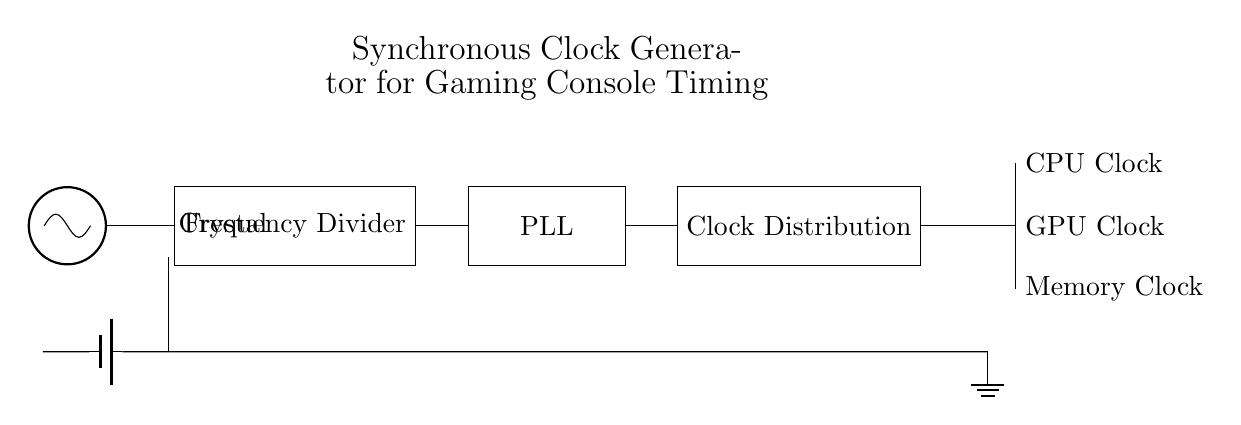What does the oscillator generate? The oscillator generates a timing signal for the clock generator. Its role is essential for synchronous circuits as it provides a stable frequency reference.
Answer: Timing signal What connects the oscillator to the frequency divider? The oscillator is connected to the frequency divider by a direct wire, allowing the generated signal to be divided in frequency for different components of the console.
Answer: A direct wire What is the function of the phase-locked loop (PLL)? The PLL synchronizes the output of the frequency divider to ensure stable clock signals are provided to the distribution network, which is critical for proper timing in the gaming console.
Answer: Synchronization How many output clock signals are shown in the clock distribution network? There are three output clock signals depicted: one for the CPU, one for the GPU, and one for memory, indicating the multi-channel capabilities of this clock generation circuit.
Answer: Three What component provides the necessary power to this circuit? A battery provides the power supply to the circuit, ensuring all components receive the voltage needed for operation.
Answer: Battery Which component directly receives input from the frequency divider? The phase-locked loop (PLL) directly receives input from the frequency divider, making it an integral part of the timing adjustments needed after frequency division.
Answer: Phase-locked loop 